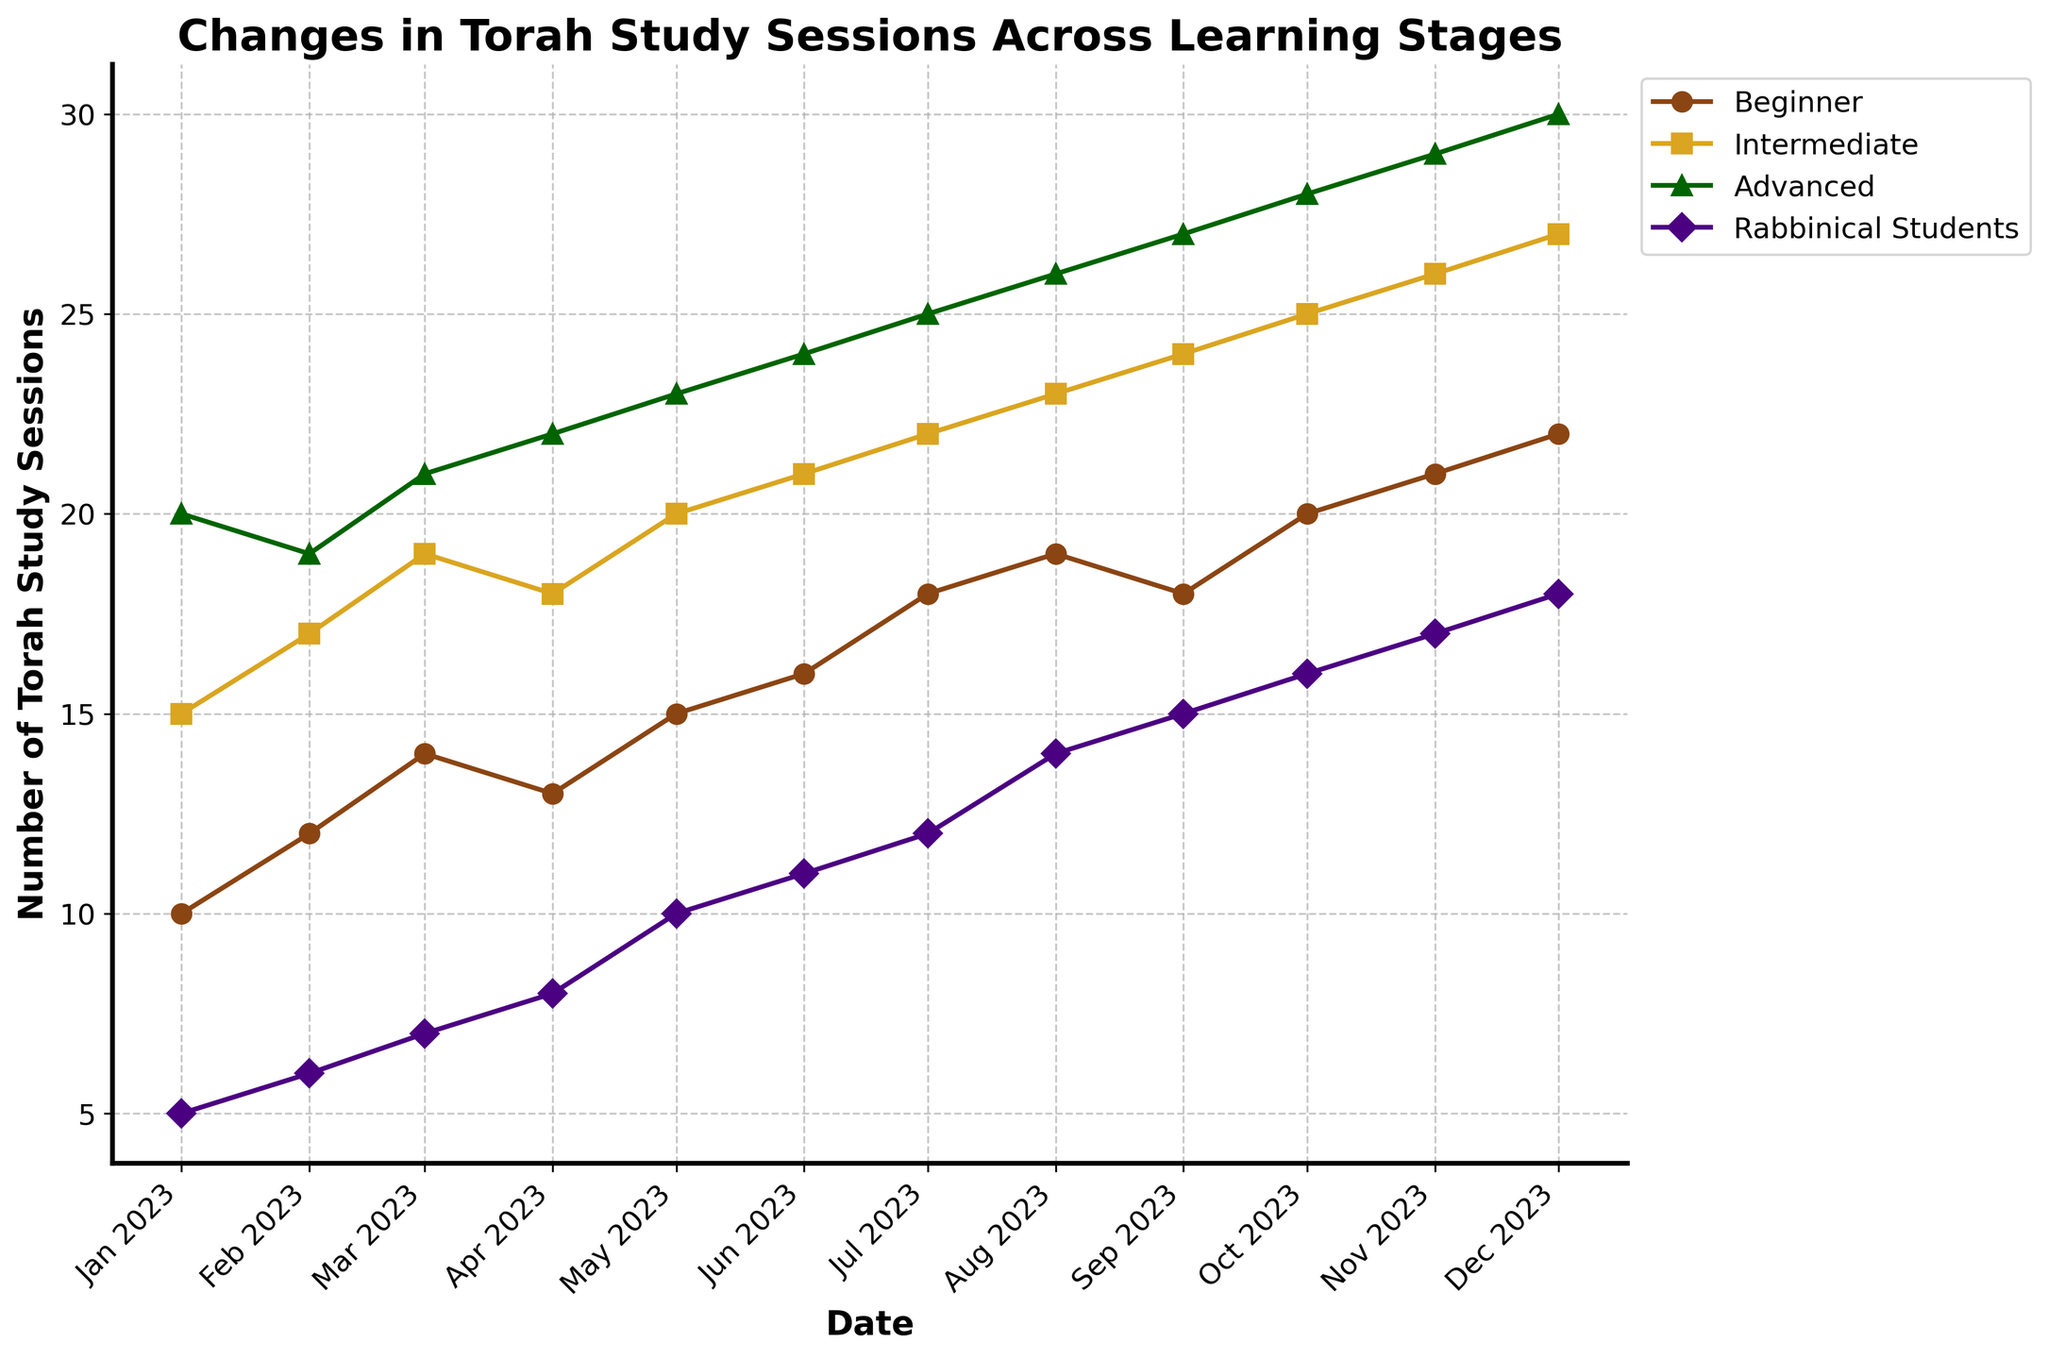What is the title of the figure? The title is located at the top of the figure and provides a summary of the content. Read the full title that is displayed
Answer: Changes in Torah Study Sessions Across Learning Stages Which learning stage has the highest number of sessions in December 2023? Locate December 2023 on the x-axis and compare the values of the different learning stages in that month. The series with the highest value represents the learning stage with the most sessions
Answer: Advanced How does the number of sessions for Rabbinical Students change from January to December 2023? Identify the values of Rabbinical Students for January and December 2023 and observe the trend over the entire year. Note whether the values are increasing, decreasing, or fluctuating
Answer: Increasing In which month do Beginner students see the highest increase in the number of study sessions? Compare the number of sessions for Beginner students month-over-month and identify the month with the highest increase from the previous month
Answer: October How does the trend of the number of study sessions for Advanced students compare to that of Rabbinical Students throughout the year? Observe the patterns for both Advanced students and Rabbinical students from January to December. Note if both lines generally increase, decrease, or have similar fluctuations
Answer: Both trends show a general increase Which learning stage consistently sees an increase in the number of sessions each month? Track the number of sessions month-by-month for each learning stage and determine which one shows a consistent month-over-month increase
Answer: Rabbinical Students Are there any months where the number of Intermediate student sessions decreases? Examine the trend line for Intermediate students and identify any month where the number of sessions is lower than the previous month
Answer: Yes, April Which month shows the greatest number of total study sessions across all learning stages? Sum the number of sessions for all learning stages for each month and identify the month with the highest total
Answer: December 